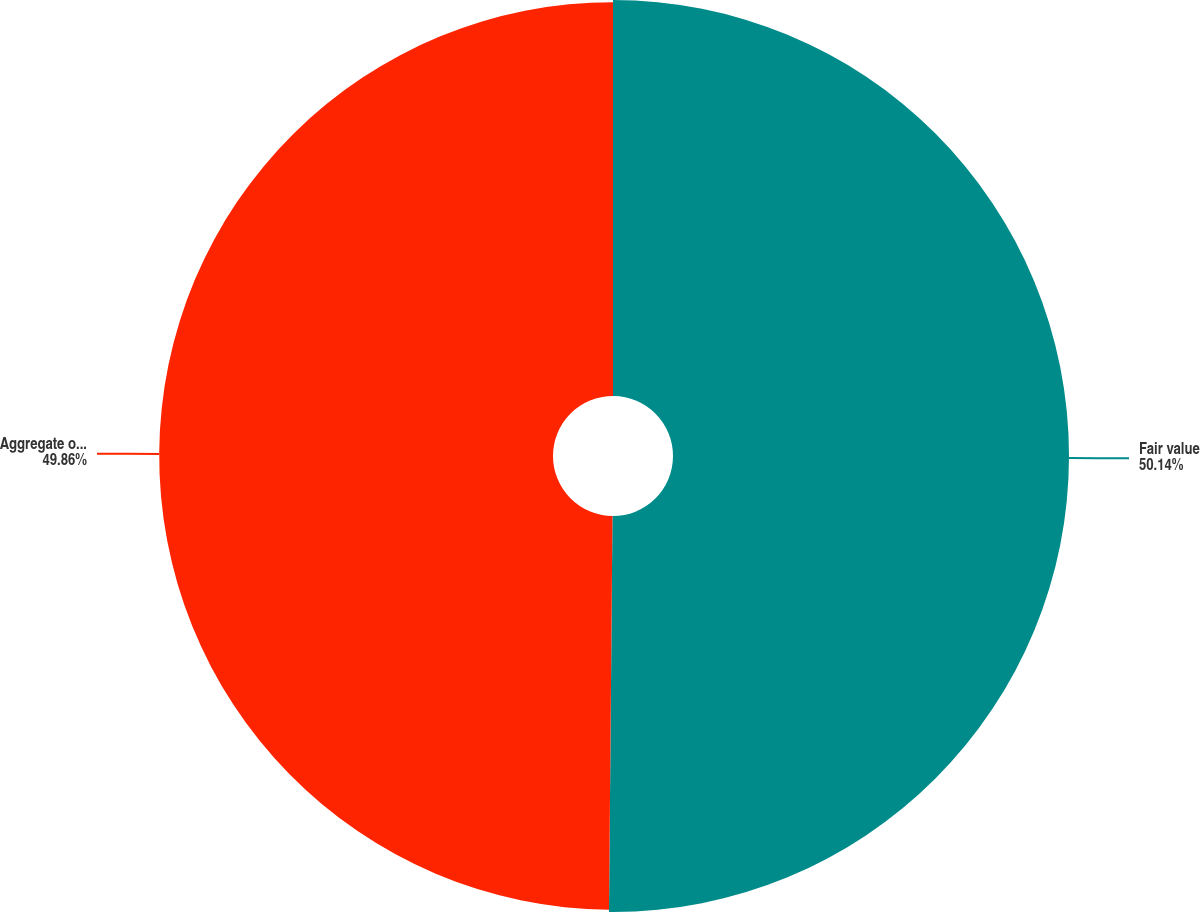<chart> <loc_0><loc_0><loc_500><loc_500><pie_chart><fcel>Fair value<fcel>Aggregate outstanding<nl><fcel>50.14%<fcel>49.86%<nl></chart> 